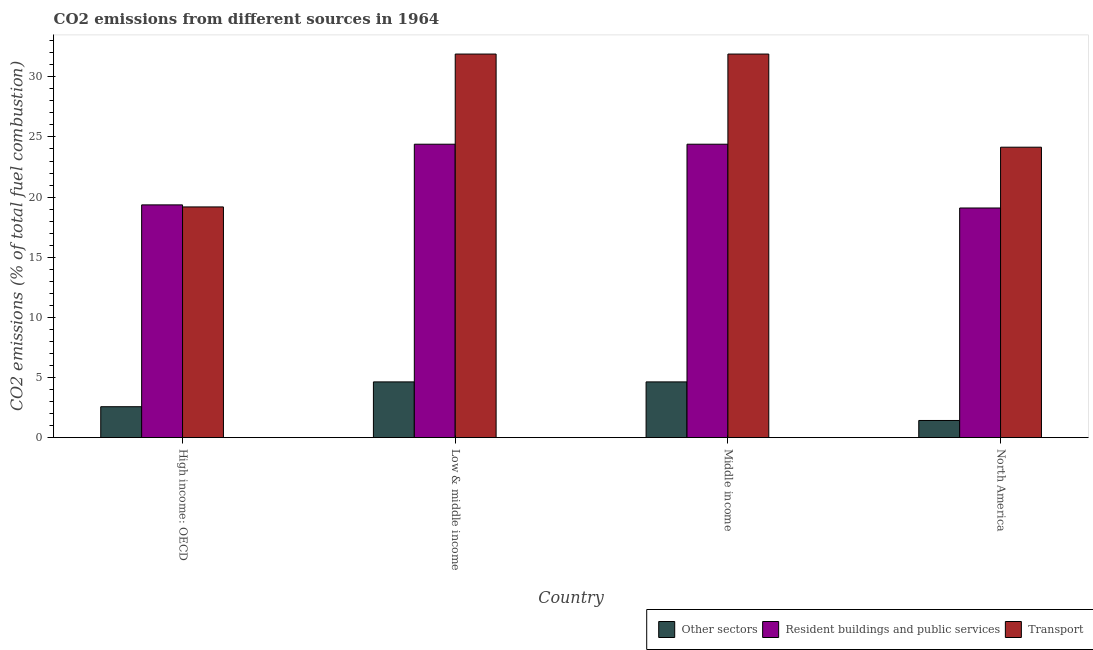How many different coloured bars are there?
Your response must be concise. 3. How many groups of bars are there?
Provide a succinct answer. 4. Are the number of bars per tick equal to the number of legend labels?
Provide a short and direct response. Yes. Are the number of bars on each tick of the X-axis equal?
Your answer should be compact. Yes. How many bars are there on the 2nd tick from the left?
Provide a succinct answer. 3. How many bars are there on the 1st tick from the right?
Provide a short and direct response. 3. What is the percentage of co2 emissions from transport in North America?
Provide a short and direct response. 24.15. Across all countries, what is the maximum percentage of co2 emissions from other sectors?
Your answer should be very brief. 4.63. Across all countries, what is the minimum percentage of co2 emissions from transport?
Ensure brevity in your answer.  19.18. In which country was the percentage of co2 emissions from other sectors minimum?
Offer a terse response. North America. What is the total percentage of co2 emissions from resident buildings and public services in the graph?
Offer a very short reply. 87.24. What is the difference between the percentage of co2 emissions from transport in High income: OECD and that in Low & middle income?
Give a very brief answer. -12.71. What is the difference between the percentage of co2 emissions from other sectors in High income: OECD and the percentage of co2 emissions from resident buildings and public services in North America?
Your answer should be compact. -16.52. What is the average percentage of co2 emissions from other sectors per country?
Make the answer very short. 3.32. What is the difference between the percentage of co2 emissions from resident buildings and public services and percentage of co2 emissions from transport in North America?
Offer a terse response. -5.06. In how many countries, is the percentage of co2 emissions from transport greater than 15 %?
Make the answer very short. 4. What is the ratio of the percentage of co2 emissions from other sectors in High income: OECD to that in Middle income?
Your answer should be very brief. 0.55. What is the difference between the highest and the second highest percentage of co2 emissions from transport?
Offer a very short reply. 0. What is the difference between the highest and the lowest percentage of co2 emissions from resident buildings and public services?
Your answer should be very brief. 5.3. What does the 2nd bar from the left in High income: OECD represents?
Provide a succinct answer. Resident buildings and public services. What does the 3rd bar from the right in High income: OECD represents?
Ensure brevity in your answer.  Other sectors. Are all the bars in the graph horizontal?
Provide a succinct answer. No. What is the difference between two consecutive major ticks on the Y-axis?
Your answer should be very brief. 5. Are the values on the major ticks of Y-axis written in scientific E-notation?
Give a very brief answer. No. Does the graph contain any zero values?
Offer a terse response. No. What is the title of the graph?
Your answer should be very brief. CO2 emissions from different sources in 1964. Does "Food" appear as one of the legend labels in the graph?
Keep it short and to the point. No. What is the label or title of the X-axis?
Keep it short and to the point. Country. What is the label or title of the Y-axis?
Keep it short and to the point. CO2 emissions (% of total fuel combustion). What is the CO2 emissions (% of total fuel combustion) of Other sectors in High income: OECD?
Your answer should be very brief. 2.57. What is the CO2 emissions (% of total fuel combustion) of Resident buildings and public services in High income: OECD?
Keep it short and to the point. 19.35. What is the CO2 emissions (% of total fuel combustion) in Transport in High income: OECD?
Provide a short and direct response. 19.18. What is the CO2 emissions (% of total fuel combustion) in Other sectors in Low & middle income?
Your answer should be very brief. 4.63. What is the CO2 emissions (% of total fuel combustion) of Resident buildings and public services in Low & middle income?
Provide a short and direct response. 24.4. What is the CO2 emissions (% of total fuel combustion) of Transport in Low & middle income?
Keep it short and to the point. 31.89. What is the CO2 emissions (% of total fuel combustion) of Other sectors in Middle income?
Your answer should be very brief. 4.63. What is the CO2 emissions (% of total fuel combustion) in Resident buildings and public services in Middle income?
Give a very brief answer. 24.4. What is the CO2 emissions (% of total fuel combustion) in Transport in Middle income?
Offer a very short reply. 31.89. What is the CO2 emissions (% of total fuel combustion) of Other sectors in North America?
Give a very brief answer. 1.43. What is the CO2 emissions (% of total fuel combustion) of Resident buildings and public services in North America?
Keep it short and to the point. 19.09. What is the CO2 emissions (% of total fuel combustion) of Transport in North America?
Offer a very short reply. 24.15. Across all countries, what is the maximum CO2 emissions (% of total fuel combustion) of Other sectors?
Give a very brief answer. 4.63. Across all countries, what is the maximum CO2 emissions (% of total fuel combustion) of Resident buildings and public services?
Your answer should be compact. 24.4. Across all countries, what is the maximum CO2 emissions (% of total fuel combustion) in Transport?
Offer a very short reply. 31.89. Across all countries, what is the minimum CO2 emissions (% of total fuel combustion) in Other sectors?
Provide a short and direct response. 1.43. Across all countries, what is the minimum CO2 emissions (% of total fuel combustion) of Resident buildings and public services?
Your answer should be very brief. 19.09. Across all countries, what is the minimum CO2 emissions (% of total fuel combustion) in Transport?
Your response must be concise. 19.18. What is the total CO2 emissions (% of total fuel combustion) of Other sectors in the graph?
Keep it short and to the point. 13.27. What is the total CO2 emissions (% of total fuel combustion) of Resident buildings and public services in the graph?
Provide a short and direct response. 87.24. What is the total CO2 emissions (% of total fuel combustion) of Transport in the graph?
Offer a very short reply. 107.12. What is the difference between the CO2 emissions (% of total fuel combustion) of Other sectors in High income: OECD and that in Low & middle income?
Provide a succinct answer. -2.06. What is the difference between the CO2 emissions (% of total fuel combustion) of Resident buildings and public services in High income: OECD and that in Low & middle income?
Your answer should be very brief. -5.04. What is the difference between the CO2 emissions (% of total fuel combustion) in Transport in High income: OECD and that in Low & middle income?
Your response must be concise. -12.71. What is the difference between the CO2 emissions (% of total fuel combustion) in Other sectors in High income: OECD and that in Middle income?
Keep it short and to the point. -2.06. What is the difference between the CO2 emissions (% of total fuel combustion) in Resident buildings and public services in High income: OECD and that in Middle income?
Give a very brief answer. -5.04. What is the difference between the CO2 emissions (% of total fuel combustion) in Transport in High income: OECD and that in Middle income?
Ensure brevity in your answer.  -12.71. What is the difference between the CO2 emissions (% of total fuel combustion) of Other sectors in High income: OECD and that in North America?
Offer a very short reply. 1.14. What is the difference between the CO2 emissions (% of total fuel combustion) in Resident buildings and public services in High income: OECD and that in North America?
Your answer should be compact. 0.26. What is the difference between the CO2 emissions (% of total fuel combustion) of Transport in High income: OECD and that in North America?
Your answer should be compact. -4.97. What is the difference between the CO2 emissions (% of total fuel combustion) of Other sectors in Low & middle income and that in Middle income?
Offer a very short reply. 0. What is the difference between the CO2 emissions (% of total fuel combustion) of Transport in Low & middle income and that in Middle income?
Offer a very short reply. 0. What is the difference between the CO2 emissions (% of total fuel combustion) of Other sectors in Low & middle income and that in North America?
Your answer should be compact. 3.21. What is the difference between the CO2 emissions (% of total fuel combustion) in Resident buildings and public services in Low & middle income and that in North America?
Provide a short and direct response. 5.3. What is the difference between the CO2 emissions (% of total fuel combustion) in Transport in Low & middle income and that in North America?
Your answer should be compact. 7.74. What is the difference between the CO2 emissions (% of total fuel combustion) in Other sectors in Middle income and that in North America?
Your response must be concise. 3.21. What is the difference between the CO2 emissions (% of total fuel combustion) of Resident buildings and public services in Middle income and that in North America?
Provide a short and direct response. 5.3. What is the difference between the CO2 emissions (% of total fuel combustion) of Transport in Middle income and that in North America?
Make the answer very short. 7.74. What is the difference between the CO2 emissions (% of total fuel combustion) of Other sectors in High income: OECD and the CO2 emissions (% of total fuel combustion) of Resident buildings and public services in Low & middle income?
Offer a terse response. -21.83. What is the difference between the CO2 emissions (% of total fuel combustion) of Other sectors in High income: OECD and the CO2 emissions (% of total fuel combustion) of Transport in Low & middle income?
Your response must be concise. -29.32. What is the difference between the CO2 emissions (% of total fuel combustion) in Resident buildings and public services in High income: OECD and the CO2 emissions (% of total fuel combustion) in Transport in Low & middle income?
Your answer should be very brief. -12.54. What is the difference between the CO2 emissions (% of total fuel combustion) of Other sectors in High income: OECD and the CO2 emissions (% of total fuel combustion) of Resident buildings and public services in Middle income?
Provide a succinct answer. -21.83. What is the difference between the CO2 emissions (% of total fuel combustion) of Other sectors in High income: OECD and the CO2 emissions (% of total fuel combustion) of Transport in Middle income?
Offer a very short reply. -29.32. What is the difference between the CO2 emissions (% of total fuel combustion) of Resident buildings and public services in High income: OECD and the CO2 emissions (% of total fuel combustion) of Transport in Middle income?
Make the answer very short. -12.54. What is the difference between the CO2 emissions (% of total fuel combustion) of Other sectors in High income: OECD and the CO2 emissions (% of total fuel combustion) of Resident buildings and public services in North America?
Make the answer very short. -16.52. What is the difference between the CO2 emissions (% of total fuel combustion) of Other sectors in High income: OECD and the CO2 emissions (% of total fuel combustion) of Transport in North America?
Make the answer very short. -21.58. What is the difference between the CO2 emissions (% of total fuel combustion) of Resident buildings and public services in High income: OECD and the CO2 emissions (% of total fuel combustion) of Transport in North America?
Offer a very short reply. -4.8. What is the difference between the CO2 emissions (% of total fuel combustion) of Other sectors in Low & middle income and the CO2 emissions (% of total fuel combustion) of Resident buildings and public services in Middle income?
Make the answer very short. -19.76. What is the difference between the CO2 emissions (% of total fuel combustion) of Other sectors in Low & middle income and the CO2 emissions (% of total fuel combustion) of Transport in Middle income?
Offer a very short reply. -27.26. What is the difference between the CO2 emissions (% of total fuel combustion) in Resident buildings and public services in Low & middle income and the CO2 emissions (% of total fuel combustion) in Transport in Middle income?
Your answer should be compact. -7.5. What is the difference between the CO2 emissions (% of total fuel combustion) of Other sectors in Low & middle income and the CO2 emissions (% of total fuel combustion) of Resident buildings and public services in North America?
Provide a short and direct response. -14.46. What is the difference between the CO2 emissions (% of total fuel combustion) of Other sectors in Low & middle income and the CO2 emissions (% of total fuel combustion) of Transport in North America?
Offer a very short reply. -19.52. What is the difference between the CO2 emissions (% of total fuel combustion) of Resident buildings and public services in Low & middle income and the CO2 emissions (% of total fuel combustion) of Transport in North America?
Make the answer very short. 0.25. What is the difference between the CO2 emissions (% of total fuel combustion) of Other sectors in Middle income and the CO2 emissions (% of total fuel combustion) of Resident buildings and public services in North America?
Your answer should be very brief. -14.46. What is the difference between the CO2 emissions (% of total fuel combustion) in Other sectors in Middle income and the CO2 emissions (% of total fuel combustion) in Transport in North America?
Your response must be concise. -19.52. What is the difference between the CO2 emissions (% of total fuel combustion) of Resident buildings and public services in Middle income and the CO2 emissions (% of total fuel combustion) of Transport in North America?
Provide a short and direct response. 0.25. What is the average CO2 emissions (% of total fuel combustion) of Other sectors per country?
Make the answer very short. 3.32. What is the average CO2 emissions (% of total fuel combustion) of Resident buildings and public services per country?
Ensure brevity in your answer.  21.81. What is the average CO2 emissions (% of total fuel combustion) in Transport per country?
Make the answer very short. 26.78. What is the difference between the CO2 emissions (% of total fuel combustion) of Other sectors and CO2 emissions (% of total fuel combustion) of Resident buildings and public services in High income: OECD?
Ensure brevity in your answer.  -16.78. What is the difference between the CO2 emissions (% of total fuel combustion) in Other sectors and CO2 emissions (% of total fuel combustion) in Transport in High income: OECD?
Give a very brief answer. -16.61. What is the difference between the CO2 emissions (% of total fuel combustion) of Resident buildings and public services and CO2 emissions (% of total fuel combustion) of Transport in High income: OECD?
Make the answer very short. 0.17. What is the difference between the CO2 emissions (% of total fuel combustion) of Other sectors and CO2 emissions (% of total fuel combustion) of Resident buildings and public services in Low & middle income?
Your response must be concise. -19.76. What is the difference between the CO2 emissions (% of total fuel combustion) in Other sectors and CO2 emissions (% of total fuel combustion) in Transport in Low & middle income?
Offer a very short reply. -27.26. What is the difference between the CO2 emissions (% of total fuel combustion) in Resident buildings and public services and CO2 emissions (% of total fuel combustion) in Transport in Low & middle income?
Ensure brevity in your answer.  -7.5. What is the difference between the CO2 emissions (% of total fuel combustion) of Other sectors and CO2 emissions (% of total fuel combustion) of Resident buildings and public services in Middle income?
Keep it short and to the point. -19.76. What is the difference between the CO2 emissions (% of total fuel combustion) of Other sectors and CO2 emissions (% of total fuel combustion) of Transport in Middle income?
Offer a very short reply. -27.26. What is the difference between the CO2 emissions (% of total fuel combustion) in Resident buildings and public services and CO2 emissions (% of total fuel combustion) in Transport in Middle income?
Ensure brevity in your answer.  -7.5. What is the difference between the CO2 emissions (% of total fuel combustion) in Other sectors and CO2 emissions (% of total fuel combustion) in Resident buildings and public services in North America?
Your answer should be compact. -17.67. What is the difference between the CO2 emissions (% of total fuel combustion) in Other sectors and CO2 emissions (% of total fuel combustion) in Transport in North America?
Provide a succinct answer. -22.72. What is the difference between the CO2 emissions (% of total fuel combustion) of Resident buildings and public services and CO2 emissions (% of total fuel combustion) of Transport in North America?
Provide a short and direct response. -5.06. What is the ratio of the CO2 emissions (% of total fuel combustion) of Other sectors in High income: OECD to that in Low & middle income?
Keep it short and to the point. 0.55. What is the ratio of the CO2 emissions (% of total fuel combustion) in Resident buildings and public services in High income: OECD to that in Low & middle income?
Your answer should be very brief. 0.79. What is the ratio of the CO2 emissions (% of total fuel combustion) in Transport in High income: OECD to that in Low & middle income?
Your response must be concise. 0.6. What is the ratio of the CO2 emissions (% of total fuel combustion) of Other sectors in High income: OECD to that in Middle income?
Offer a very short reply. 0.55. What is the ratio of the CO2 emissions (% of total fuel combustion) in Resident buildings and public services in High income: OECD to that in Middle income?
Your answer should be compact. 0.79. What is the ratio of the CO2 emissions (% of total fuel combustion) in Transport in High income: OECD to that in Middle income?
Provide a succinct answer. 0.6. What is the ratio of the CO2 emissions (% of total fuel combustion) of Other sectors in High income: OECD to that in North America?
Your response must be concise. 1.8. What is the ratio of the CO2 emissions (% of total fuel combustion) of Resident buildings and public services in High income: OECD to that in North America?
Your response must be concise. 1.01. What is the ratio of the CO2 emissions (% of total fuel combustion) in Transport in High income: OECD to that in North America?
Your answer should be very brief. 0.79. What is the ratio of the CO2 emissions (% of total fuel combustion) in Other sectors in Low & middle income to that in Middle income?
Your response must be concise. 1. What is the ratio of the CO2 emissions (% of total fuel combustion) in Resident buildings and public services in Low & middle income to that in Middle income?
Your response must be concise. 1. What is the ratio of the CO2 emissions (% of total fuel combustion) of Other sectors in Low & middle income to that in North America?
Provide a succinct answer. 3.25. What is the ratio of the CO2 emissions (% of total fuel combustion) in Resident buildings and public services in Low & middle income to that in North America?
Offer a very short reply. 1.28. What is the ratio of the CO2 emissions (% of total fuel combustion) of Transport in Low & middle income to that in North America?
Ensure brevity in your answer.  1.32. What is the ratio of the CO2 emissions (% of total fuel combustion) of Other sectors in Middle income to that in North America?
Your answer should be very brief. 3.25. What is the ratio of the CO2 emissions (% of total fuel combustion) of Resident buildings and public services in Middle income to that in North America?
Your answer should be very brief. 1.28. What is the ratio of the CO2 emissions (% of total fuel combustion) in Transport in Middle income to that in North America?
Provide a succinct answer. 1.32. What is the difference between the highest and the second highest CO2 emissions (% of total fuel combustion) of Other sectors?
Provide a succinct answer. 0. What is the difference between the highest and the lowest CO2 emissions (% of total fuel combustion) of Other sectors?
Offer a very short reply. 3.21. What is the difference between the highest and the lowest CO2 emissions (% of total fuel combustion) of Resident buildings and public services?
Offer a very short reply. 5.3. What is the difference between the highest and the lowest CO2 emissions (% of total fuel combustion) in Transport?
Provide a succinct answer. 12.71. 